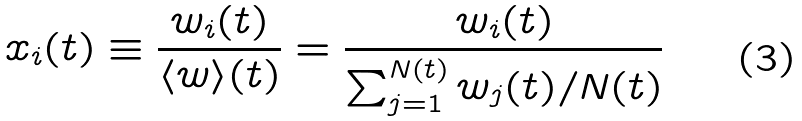Convert formula to latex. <formula><loc_0><loc_0><loc_500><loc_500>x _ { i } ( t ) \equiv \frac { w _ { i } ( t ) } { \langle w \rangle ( t ) } = \frac { w _ { i } ( t ) } { \sum _ { j = 1 } ^ { N ( t ) } w _ { j } ( t ) / N ( t ) }</formula> 